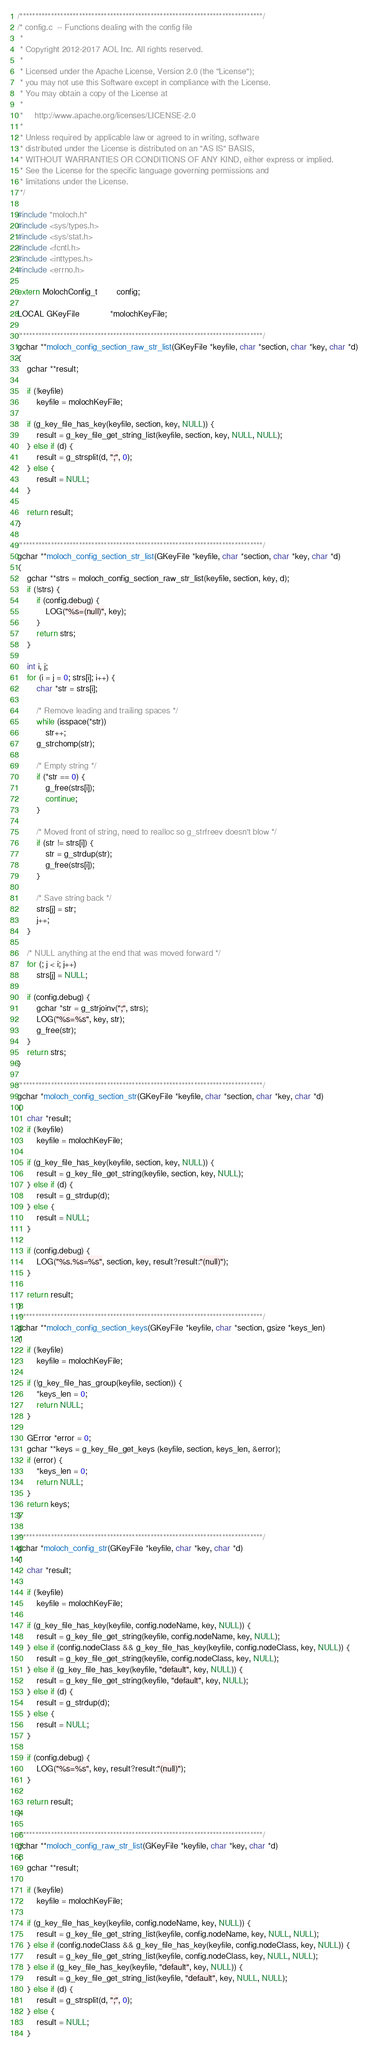<code> <loc_0><loc_0><loc_500><loc_500><_C_>/******************************************************************************/
/* config.c  -- Functions dealing with the config file
 *
 * Copyright 2012-2017 AOL Inc. All rights reserved.
 *
 * Licensed under the Apache License, Version 2.0 (the "License");
 * you may not use this Software except in compliance with the License.
 * You may obtain a copy of the License at
 *
 *     http://www.apache.org/licenses/LICENSE-2.0
 *
 * Unless required by applicable law or agreed to in writing, software
 * distributed under the License is distributed on an "AS IS" BASIS,
 * WITHOUT WARRANTIES OR CONDITIONS OF ANY KIND, either express or implied.
 * See the License for the specific language governing permissions and
 * limitations under the License.
 */

#include "moloch.h"
#include <sys/types.h>
#include <sys/stat.h>
#include <fcntl.h>
#include <inttypes.h>
#include <errno.h>

extern MolochConfig_t        config;

LOCAL GKeyFile             *molochKeyFile;

/******************************************************************************/
gchar **moloch_config_section_raw_str_list(GKeyFile *keyfile, char *section, char *key, char *d)
{
    gchar **result;

    if (!keyfile)
        keyfile = molochKeyFile;

    if (g_key_file_has_key(keyfile, section, key, NULL)) {
        result = g_key_file_get_string_list(keyfile, section, key, NULL, NULL);
    } else if (d) {
        result = g_strsplit(d, ";", 0);
    } else {
        result = NULL;
    }

    return result;
}

/******************************************************************************/
gchar **moloch_config_section_str_list(GKeyFile *keyfile, char *section, char *key, char *d)
{
    gchar **strs = moloch_config_section_raw_str_list(keyfile, section, key, d);
    if (!strs) {
        if (config.debug) {
            LOG("%s=(null)", key);
        }
        return strs;
    }

    int i, j;
    for (i = j = 0; strs[i]; i++) {
        char *str = strs[i];

        /* Remove leading and trailing spaces */
        while (isspace(*str))
            str++;
        g_strchomp(str);

        /* Empty string */
        if (*str == 0) {
            g_free(strs[i]);
            continue;
        }

        /* Moved front of string, need to realloc so g_strfreev doesn't blow */
        if (str != strs[i]) {
            str = g_strdup(str);
            g_free(strs[i]);
        }

        /* Save string back */
        strs[j] = str;
        j++;
    }

    /* NULL anything at the end that was moved forward */
    for (; j < i; j++)
        strs[j] = NULL;

    if (config.debug) {
        gchar *str = g_strjoinv(";", strs);
        LOG("%s=%s", key, str);
        g_free(str);
    }
    return strs;
}

/******************************************************************************/
gchar *moloch_config_section_str(GKeyFile *keyfile, char *section, char *key, char *d)
{
    char *result;
    if (!keyfile)
        keyfile = molochKeyFile;

    if (g_key_file_has_key(keyfile, section, key, NULL)) {
        result = g_key_file_get_string(keyfile, section, key, NULL);
    } else if (d) {
        result = g_strdup(d);
    } else {
        result = NULL;
    }

    if (config.debug) {
        LOG("%s.%s=%s", section, key, result?result:"(null)");
    }

    return result;
}
/******************************************************************************/
gchar **moloch_config_section_keys(GKeyFile *keyfile, char *section, gsize *keys_len)
{
    if (!keyfile)
        keyfile = molochKeyFile;

    if (!g_key_file_has_group(keyfile, section)) {
        *keys_len = 0;
        return NULL;
    }

    GError *error = 0;
    gchar **keys = g_key_file_get_keys (keyfile, section, keys_len, &error);
    if (error) {
        *keys_len = 0;
        return NULL;
    }
    return keys;
}

/******************************************************************************/
gchar *moloch_config_str(GKeyFile *keyfile, char *key, char *d)
{
    char *result;

    if (!keyfile)
        keyfile = molochKeyFile;

    if (g_key_file_has_key(keyfile, config.nodeName, key, NULL)) {
        result = g_key_file_get_string(keyfile, config.nodeName, key, NULL);
    } else if (config.nodeClass && g_key_file_has_key(keyfile, config.nodeClass, key, NULL)) {
        result = g_key_file_get_string(keyfile, config.nodeClass, key, NULL);
    } else if (g_key_file_has_key(keyfile, "default", key, NULL)) {
        result = g_key_file_get_string(keyfile, "default", key, NULL);
    } else if (d) {
        result = g_strdup(d);
    } else {
        result = NULL;
    }

    if (config.debug) {
        LOG("%s=%s", key, result?result:"(null)");
    }

    return result;
}

/******************************************************************************/
gchar **moloch_config_raw_str_list(GKeyFile *keyfile, char *key, char *d)
{
    gchar **result;

    if (!keyfile)
        keyfile = molochKeyFile;

    if (g_key_file_has_key(keyfile, config.nodeName, key, NULL)) {
        result = g_key_file_get_string_list(keyfile, config.nodeName, key, NULL, NULL);
    } else if (config.nodeClass && g_key_file_has_key(keyfile, config.nodeClass, key, NULL)) {
        result = g_key_file_get_string_list(keyfile, config.nodeClass, key, NULL, NULL);
    } else if (g_key_file_has_key(keyfile, "default", key, NULL)) {
        result = g_key_file_get_string_list(keyfile, "default", key, NULL, NULL);
    } else if (d) {
        result = g_strsplit(d, ";", 0);
    } else {
        result = NULL;
    }
</code> 